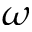<formula> <loc_0><loc_0><loc_500><loc_500>\omega</formula> 